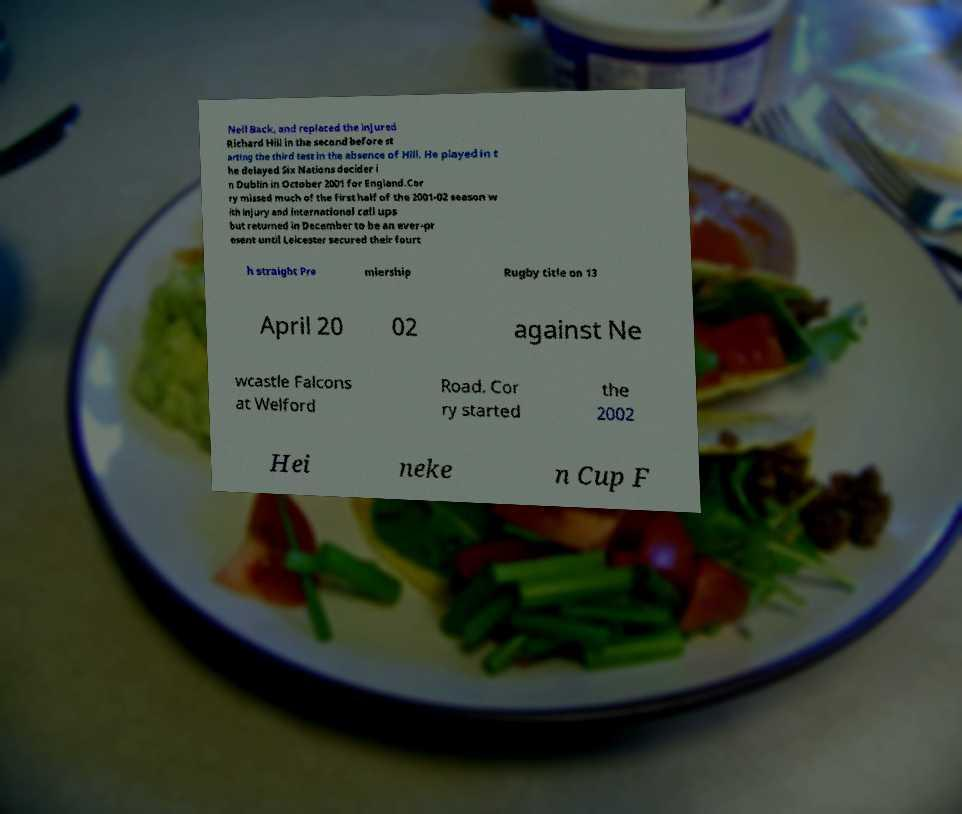Can you read and provide the text displayed in the image?This photo seems to have some interesting text. Can you extract and type it out for me? Neil Back, and replaced the injured Richard Hill in the second before st arting the third test in the absence of Hill. He played in t he delayed Six Nations decider i n Dublin in October 2001 for England.Cor ry missed much of the first half of the 2001-02 season w ith injury and international call ups but returned in December to be an ever-pr esent until Leicester secured their fourt h straight Pre miership Rugby title on 13 April 20 02 against Ne wcastle Falcons at Welford Road. Cor ry started the 2002 Hei neke n Cup F 